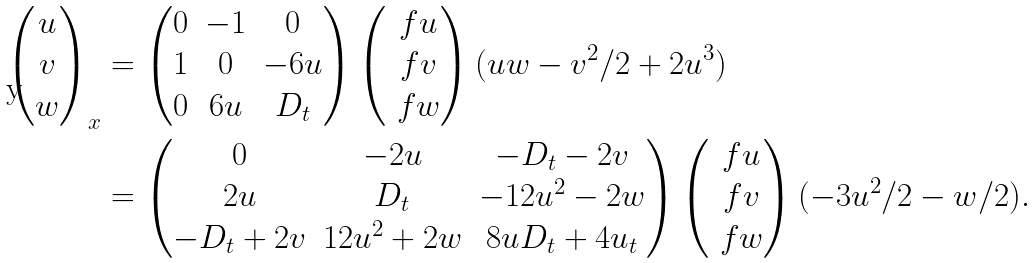Convert formula to latex. <formula><loc_0><loc_0><loc_500><loc_500>\begin{pmatrix} u \\ v \\ w \end{pmatrix} _ { x } & = \begin{pmatrix} 0 & - 1 & 0 \\ 1 & 0 & - 6 u \\ 0 & 6 u & D _ { t } \end{pmatrix} \begin{pmatrix} \ f { u } \\ \ f { v } \\ \ f { w } \end{pmatrix} ( u w - v ^ { 2 } / 2 + 2 u ^ { 3 } ) \\ & = \begin{pmatrix} 0 & - 2 u & - D _ { t } - 2 v \\ 2 u & D _ { t } & - 1 2 u ^ { 2 } - 2 w \\ - D _ { t } + 2 v & 1 2 u ^ { 2 } + 2 w & 8 u D _ { t } + 4 u _ { t } \end{pmatrix} \begin{pmatrix} \ f { u } \\ \ f { v } \\ \ f { w } \end{pmatrix} ( - 3 u ^ { 2 } / 2 - w / 2 ) .</formula> 